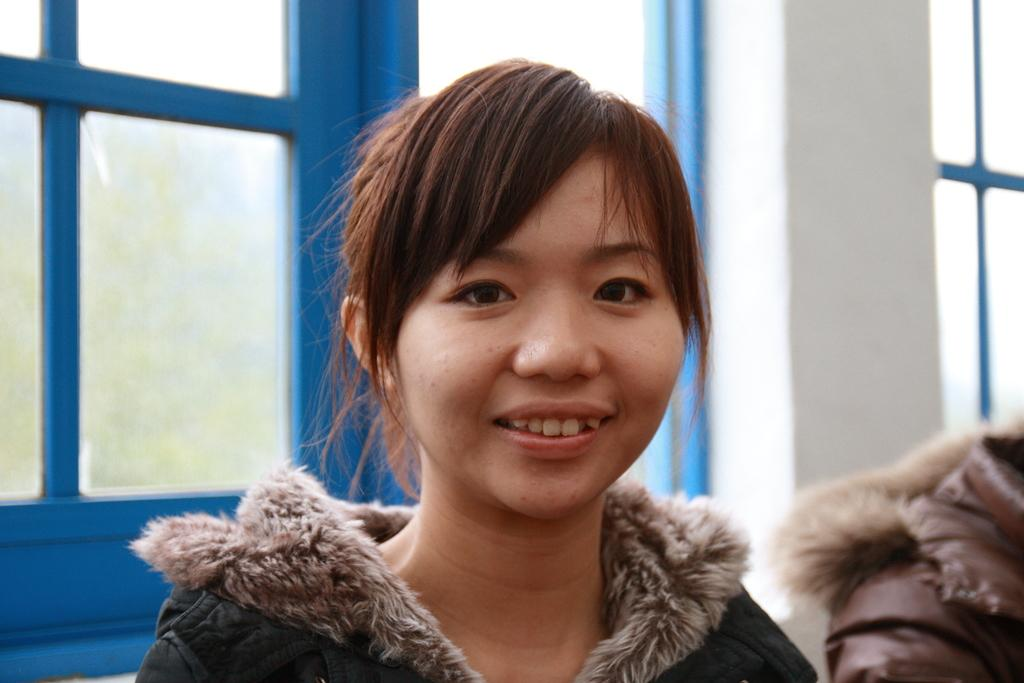Who is present in the image? There is a woman in the image. What can be seen in the background of the image? There is a glass window in the background of the image. What type of structure is visible in the image? There is a wall visible in the image. How many cherries are on the woman's head in the image? There are no cherries present on the woman's head in the image. What type of light can be seen coming from the glass window in the image? The image does not provide information about the type of light coming from the glass window, as it only mentions the presence of a glass window in the background. 